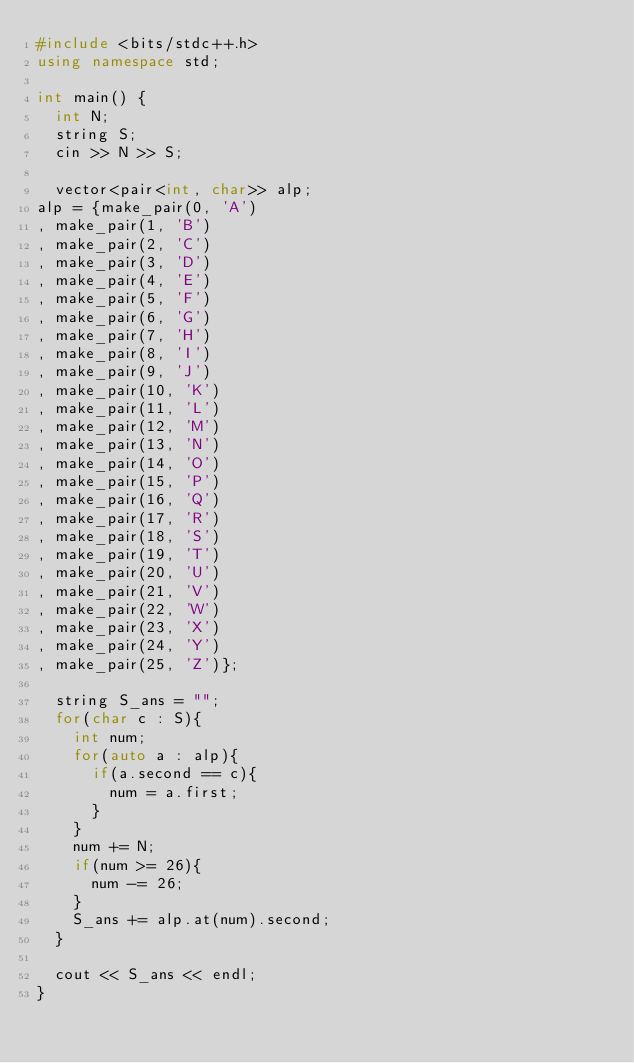Convert code to text. <code><loc_0><loc_0><loc_500><loc_500><_C++_>#include <bits/stdc++.h>
using namespace std;
 
int main() {
  int N;
  string S;
  cin >> N >> S;
  
  vector<pair<int, char>> alp;
alp = {make_pair(0, 'A')
, make_pair(1, 'B')
, make_pair(2, 'C')
, make_pair(3, 'D')
, make_pair(4, 'E')
, make_pair(5, 'F')
, make_pair(6, 'G')
, make_pair(7, 'H')
, make_pair(8, 'I')
, make_pair(9, 'J')
, make_pair(10, 'K')
, make_pair(11, 'L')
, make_pair(12, 'M')
, make_pair(13, 'N')
, make_pair(14, 'O')
, make_pair(15, 'P')
, make_pair(16, 'Q')
, make_pair(17, 'R')
, make_pair(18, 'S')
, make_pair(19, 'T')
, make_pair(20, 'U')
, make_pair(21, 'V')
, make_pair(22, 'W')
, make_pair(23, 'X')
, make_pair(24, 'Y')
, make_pair(25, 'Z')};
  
  string S_ans = "";
  for(char c : S){
    int num;
    for(auto a : alp){
      if(a.second == c){
        num = a.first;
      }
    }
    num += N;
    if(num >= 26){
      num -= 26;
    }
    S_ans += alp.at(num).second;
  }
  
  cout << S_ans << endl;
}</code> 